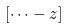<formula> <loc_0><loc_0><loc_500><loc_500>\left [ { \cdots - z } \right ]</formula> 